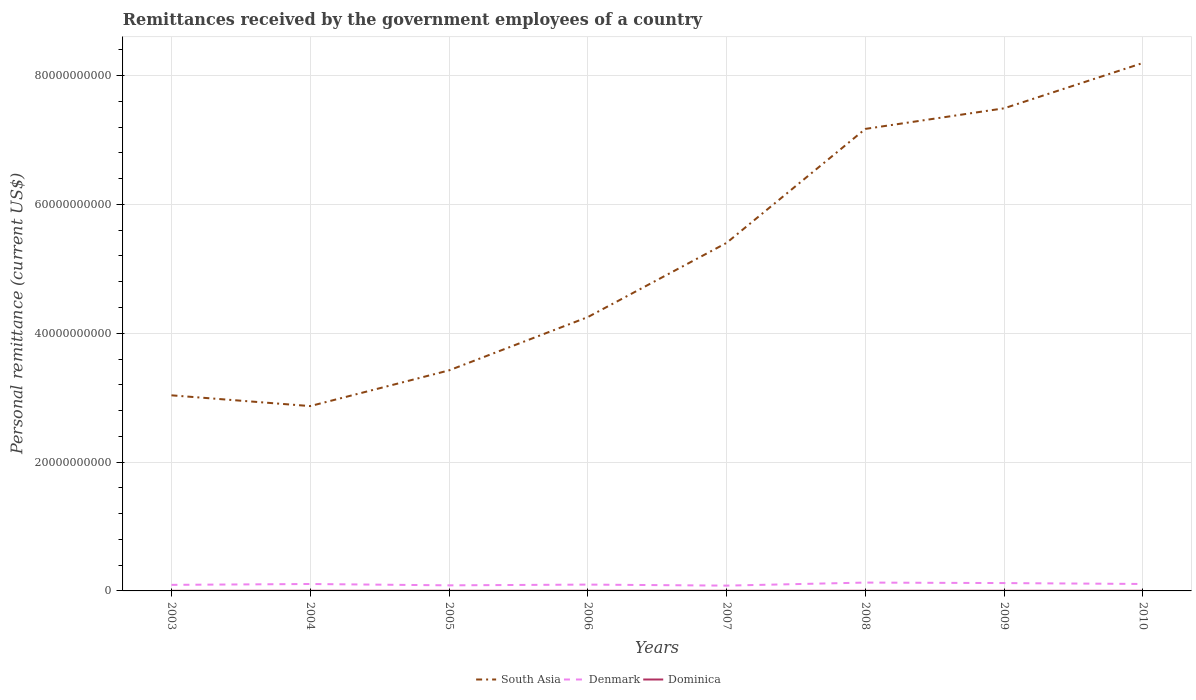Is the number of lines equal to the number of legend labels?
Give a very brief answer. Yes. Across all years, what is the maximum remittances received by the government employees in Denmark?
Keep it short and to the point. 8.23e+08. What is the total remittances received by the government employees in Denmark in the graph?
Make the answer very short. -4.19e+07. What is the difference between the highest and the second highest remittances received by the government employees in Denmark?
Provide a short and direct response. 4.73e+08. What is the difference between the highest and the lowest remittances received by the government employees in South Asia?
Give a very brief answer. 4. How many legend labels are there?
Offer a terse response. 3. What is the title of the graph?
Make the answer very short. Remittances received by the government employees of a country. Does "Paraguay" appear as one of the legend labels in the graph?
Provide a short and direct response. No. What is the label or title of the X-axis?
Offer a terse response. Years. What is the label or title of the Y-axis?
Ensure brevity in your answer.  Personal remittance (current US$). What is the Personal remittance (current US$) in South Asia in 2003?
Make the answer very short. 3.04e+1. What is the Personal remittance (current US$) in Denmark in 2003?
Provide a short and direct response. 9.41e+08. What is the Personal remittance (current US$) in Dominica in 2003?
Give a very brief answer. 1.78e+07. What is the Personal remittance (current US$) of South Asia in 2004?
Offer a very short reply. 2.87e+1. What is the Personal remittance (current US$) of Denmark in 2004?
Offer a terse response. 1.08e+09. What is the Personal remittance (current US$) of Dominica in 2004?
Your answer should be very brief. 2.32e+07. What is the Personal remittance (current US$) in South Asia in 2005?
Offer a terse response. 3.42e+1. What is the Personal remittance (current US$) of Denmark in 2005?
Your response must be concise. 8.67e+08. What is the Personal remittance (current US$) of Dominica in 2005?
Your answer should be compact. 2.18e+07. What is the Personal remittance (current US$) in South Asia in 2006?
Keep it short and to the point. 4.25e+1. What is the Personal remittance (current US$) of Denmark in 2006?
Ensure brevity in your answer.  9.82e+08. What is the Personal remittance (current US$) in Dominica in 2006?
Provide a short and direct response. 2.21e+07. What is the Personal remittance (current US$) of South Asia in 2007?
Keep it short and to the point. 5.40e+1. What is the Personal remittance (current US$) in Denmark in 2007?
Your answer should be very brief. 8.23e+08. What is the Personal remittance (current US$) of Dominica in 2007?
Keep it short and to the point. 2.25e+07. What is the Personal remittance (current US$) of South Asia in 2008?
Give a very brief answer. 7.17e+1. What is the Personal remittance (current US$) in Denmark in 2008?
Give a very brief answer. 1.30e+09. What is the Personal remittance (current US$) in Dominica in 2008?
Keep it short and to the point. 2.27e+07. What is the Personal remittance (current US$) of South Asia in 2009?
Your response must be concise. 7.49e+1. What is the Personal remittance (current US$) of Denmark in 2009?
Provide a short and direct response. 1.22e+09. What is the Personal remittance (current US$) in Dominica in 2009?
Keep it short and to the point. 2.21e+07. What is the Personal remittance (current US$) in South Asia in 2010?
Make the answer very short. 8.20e+1. What is the Personal remittance (current US$) in Denmark in 2010?
Give a very brief answer. 1.08e+09. What is the Personal remittance (current US$) of Dominica in 2010?
Provide a succinct answer. 2.29e+07. Across all years, what is the maximum Personal remittance (current US$) of South Asia?
Provide a short and direct response. 8.20e+1. Across all years, what is the maximum Personal remittance (current US$) of Denmark?
Provide a succinct answer. 1.30e+09. Across all years, what is the maximum Personal remittance (current US$) of Dominica?
Your answer should be compact. 2.32e+07. Across all years, what is the minimum Personal remittance (current US$) in South Asia?
Offer a terse response. 2.87e+1. Across all years, what is the minimum Personal remittance (current US$) of Denmark?
Your answer should be very brief. 8.23e+08. Across all years, what is the minimum Personal remittance (current US$) of Dominica?
Your response must be concise. 1.78e+07. What is the total Personal remittance (current US$) in South Asia in the graph?
Your answer should be very brief. 4.18e+11. What is the total Personal remittance (current US$) of Denmark in the graph?
Give a very brief answer. 8.28e+09. What is the total Personal remittance (current US$) in Dominica in the graph?
Give a very brief answer. 1.75e+08. What is the difference between the Personal remittance (current US$) in South Asia in 2003 and that in 2004?
Keep it short and to the point. 1.67e+09. What is the difference between the Personal remittance (current US$) in Denmark in 2003 and that in 2004?
Provide a succinct answer. -1.35e+08. What is the difference between the Personal remittance (current US$) in Dominica in 2003 and that in 2004?
Ensure brevity in your answer.  -5.33e+06. What is the difference between the Personal remittance (current US$) in South Asia in 2003 and that in 2005?
Offer a very short reply. -3.87e+09. What is the difference between the Personal remittance (current US$) in Denmark in 2003 and that in 2005?
Your answer should be compact. 7.38e+07. What is the difference between the Personal remittance (current US$) in Dominica in 2003 and that in 2005?
Offer a terse response. -3.96e+06. What is the difference between the Personal remittance (current US$) in South Asia in 2003 and that in 2006?
Give a very brief answer. -1.21e+1. What is the difference between the Personal remittance (current US$) of Denmark in 2003 and that in 2006?
Give a very brief answer. -4.19e+07. What is the difference between the Personal remittance (current US$) of Dominica in 2003 and that in 2006?
Offer a terse response. -4.26e+06. What is the difference between the Personal remittance (current US$) in South Asia in 2003 and that in 2007?
Offer a very short reply. -2.37e+1. What is the difference between the Personal remittance (current US$) of Denmark in 2003 and that in 2007?
Give a very brief answer. 1.18e+08. What is the difference between the Personal remittance (current US$) in Dominica in 2003 and that in 2007?
Your answer should be very brief. -4.67e+06. What is the difference between the Personal remittance (current US$) in South Asia in 2003 and that in 2008?
Ensure brevity in your answer.  -4.14e+1. What is the difference between the Personal remittance (current US$) in Denmark in 2003 and that in 2008?
Provide a succinct answer. -3.55e+08. What is the difference between the Personal remittance (current US$) in Dominica in 2003 and that in 2008?
Your answer should be compact. -4.87e+06. What is the difference between the Personal remittance (current US$) of South Asia in 2003 and that in 2009?
Keep it short and to the point. -4.46e+1. What is the difference between the Personal remittance (current US$) in Denmark in 2003 and that in 2009?
Your answer should be compact. -2.78e+08. What is the difference between the Personal remittance (current US$) in Dominica in 2003 and that in 2009?
Offer a terse response. -4.32e+06. What is the difference between the Personal remittance (current US$) of South Asia in 2003 and that in 2010?
Your answer should be compact. -5.16e+1. What is the difference between the Personal remittance (current US$) in Denmark in 2003 and that in 2010?
Provide a short and direct response. -1.37e+08. What is the difference between the Personal remittance (current US$) of Dominica in 2003 and that in 2010?
Provide a short and direct response. -5.07e+06. What is the difference between the Personal remittance (current US$) of South Asia in 2004 and that in 2005?
Your answer should be very brief. -5.54e+09. What is the difference between the Personal remittance (current US$) in Denmark in 2004 and that in 2005?
Your answer should be very brief. 2.09e+08. What is the difference between the Personal remittance (current US$) in Dominica in 2004 and that in 2005?
Ensure brevity in your answer.  1.38e+06. What is the difference between the Personal remittance (current US$) of South Asia in 2004 and that in 2006?
Give a very brief answer. -1.38e+1. What is the difference between the Personal remittance (current US$) of Denmark in 2004 and that in 2006?
Give a very brief answer. 9.29e+07. What is the difference between the Personal remittance (current US$) in Dominica in 2004 and that in 2006?
Make the answer very short. 1.08e+06. What is the difference between the Personal remittance (current US$) in South Asia in 2004 and that in 2007?
Make the answer very short. -2.53e+1. What is the difference between the Personal remittance (current US$) of Denmark in 2004 and that in 2007?
Give a very brief answer. 2.53e+08. What is the difference between the Personal remittance (current US$) of Dominica in 2004 and that in 2007?
Offer a terse response. 6.68e+05. What is the difference between the Personal remittance (current US$) in South Asia in 2004 and that in 2008?
Ensure brevity in your answer.  -4.30e+1. What is the difference between the Personal remittance (current US$) in Denmark in 2004 and that in 2008?
Your answer should be compact. -2.20e+08. What is the difference between the Personal remittance (current US$) in Dominica in 2004 and that in 2008?
Ensure brevity in your answer.  4.64e+05. What is the difference between the Personal remittance (current US$) of South Asia in 2004 and that in 2009?
Ensure brevity in your answer.  -4.62e+1. What is the difference between the Personal remittance (current US$) of Denmark in 2004 and that in 2009?
Keep it short and to the point. -1.44e+08. What is the difference between the Personal remittance (current US$) in Dominica in 2004 and that in 2009?
Offer a very short reply. 1.01e+06. What is the difference between the Personal remittance (current US$) in South Asia in 2004 and that in 2010?
Keep it short and to the point. -5.33e+1. What is the difference between the Personal remittance (current US$) of Denmark in 2004 and that in 2010?
Offer a terse response. -2.14e+06. What is the difference between the Personal remittance (current US$) in Dominica in 2004 and that in 2010?
Give a very brief answer. 2.61e+05. What is the difference between the Personal remittance (current US$) of South Asia in 2005 and that in 2006?
Your answer should be compact. -8.27e+09. What is the difference between the Personal remittance (current US$) of Denmark in 2005 and that in 2006?
Your answer should be compact. -1.16e+08. What is the difference between the Personal remittance (current US$) in Dominica in 2005 and that in 2006?
Your response must be concise. -3.03e+05. What is the difference between the Personal remittance (current US$) in South Asia in 2005 and that in 2007?
Make the answer very short. -1.98e+1. What is the difference between the Personal remittance (current US$) of Denmark in 2005 and that in 2007?
Provide a short and direct response. 4.39e+07. What is the difference between the Personal remittance (current US$) in Dominica in 2005 and that in 2007?
Give a very brief answer. -7.10e+05. What is the difference between the Personal remittance (current US$) of South Asia in 2005 and that in 2008?
Make the answer very short. -3.75e+1. What is the difference between the Personal remittance (current US$) of Denmark in 2005 and that in 2008?
Your answer should be compact. -4.29e+08. What is the difference between the Personal remittance (current US$) in Dominica in 2005 and that in 2008?
Your response must be concise. -9.14e+05. What is the difference between the Personal remittance (current US$) of South Asia in 2005 and that in 2009?
Offer a terse response. -4.07e+1. What is the difference between the Personal remittance (current US$) in Denmark in 2005 and that in 2009?
Keep it short and to the point. -3.52e+08. What is the difference between the Personal remittance (current US$) in Dominica in 2005 and that in 2009?
Provide a succinct answer. -3.66e+05. What is the difference between the Personal remittance (current US$) in South Asia in 2005 and that in 2010?
Offer a very short reply. -4.77e+1. What is the difference between the Personal remittance (current US$) of Denmark in 2005 and that in 2010?
Your answer should be very brief. -2.11e+08. What is the difference between the Personal remittance (current US$) in Dominica in 2005 and that in 2010?
Keep it short and to the point. -1.12e+06. What is the difference between the Personal remittance (current US$) of South Asia in 2006 and that in 2007?
Offer a terse response. -1.15e+1. What is the difference between the Personal remittance (current US$) of Denmark in 2006 and that in 2007?
Your answer should be compact. 1.60e+08. What is the difference between the Personal remittance (current US$) of Dominica in 2006 and that in 2007?
Provide a succinct answer. -4.08e+05. What is the difference between the Personal remittance (current US$) of South Asia in 2006 and that in 2008?
Offer a very short reply. -2.92e+1. What is the difference between the Personal remittance (current US$) of Denmark in 2006 and that in 2008?
Your answer should be very brief. -3.13e+08. What is the difference between the Personal remittance (current US$) in Dominica in 2006 and that in 2008?
Your answer should be compact. -6.11e+05. What is the difference between the Personal remittance (current US$) in South Asia in 2006 and that in 2009?
Offer a very short reply. -3.24e+1. What is the difference between the Personal remittance (current US$) of Denmark in 2006 and that in 2009?
Your answer should be compact. -2.36e+08. What is the difference between the Personal remittance (current US$) of Dominica in 2006 and that in 2009?
Give a very brief answer. -6.35e+04. What is the difference between the Personal remittance (current US$) in South Asia in 2006 and that in 2010?
Your answer should be compact. -3.95e+1. What is the difference between the Personal remittance (current US$) of Denmark in 2006 and that in 2010?
Make the answer very short. -9.51e+07. What is the difference between the Personal remittance (current US$) of Dominica in 2006 and that in 2010?
Give a very brief answer. -8.14e+05. What is the difference between the Personal remittance (current US$) in South Asia in 2007 and that in 2008?
Your response must be concise. -1.77e+1. What is the difference between the Personal remittance (current US$) of Denmark in 2007 and that in 2008?
Your answer should be compact. -4.73e+08. What is the difference between the Personal remittance (current US$) of Dominica in 2007 and that in 2008?
Your response must be concise. -2.04e+05. What is the difference between the Personal remittance (current US$) of South Asia in 2007 and that in 2009?
Offer a very short reply. -2.09e+1. What is the difference between the Personal remittance (current US$) of Denmark in 2007 and that in 2009?
Provide a succinct answer. -3.96e+08. What is the difference between the Personal remittance (current US$) of Dominica in 2007 and that in 2009?
Make the answer very short. 3.44e+05. What is the difference between the Personal remittance (current US$) in South Asia in 2007 and that in 2010?
Make the answer very short. -2.79e+1. What is the difference between the Personal remittance (current US$) in Denmark in 2007 and that in 2010?
Your response must be concise. -2.55e+08. What is the difference between the Personal remittance (current US$) in Dominica in 2007 and that in 2010?
Provide a short and direct response. -4.07e+05. What is the difference between the Personal remittance (current US$) of South Asia in 2008 and that in 2009?
Provide a short and direct response. -3.20e+09. What is the difference between the Personal remittance (current US$) in Denmark in 2008 and that in 2009?
Provide a short and direct response. 7.65e+07. What is the difference between the Personal remittance (current US$) of Dominica in 2008 and that in 2009?
Give a very brief answer. 5.48e+05. What is the difference between the Personal remittance (current US$) in South Asia in 2008 and that in 2010?
Keep it short and to the point. -1.02e+1. What is the difference between the Personal remittance (current US$) in Denmark in 2008 and that in 2010?
Offer a very short reply. 2.18e+08. What is the difference between the Personal remittance (current US$) in Dominica in 2008 and that in 2010?
Your answer should be very brief. -2.03e+05. What is the difference between the Personal remittance (current US$) of South Asia in 2009 and that in 2010?
Your answer should be compact. -7.04e+09. What is the difference between the Personal remittance (current US$) in Denmark in 2009 and that in 2010?
Your answer should be compact. 1.41e+08. What is the difference between the Personal remittance (current US$) in Dominica in 2009 and that in 2010?
Make the answer very short. -7.51e+05. What is the difference between the Personal remittance (current US$) in South Asia in 2003 and the Personal remittance (current US$) in Denmark in 2004?
Keep it short and to the point. 2.93e+1. What is the difference between the Personal remittance (current US$) in South Asia in 2003 and the Personal remittance (current US$) in Dominica in 2004?
Provide a short and direct response. 3.03e+1. What is the difference between the Personal remittance (current US$) in Denmark in 2003 and the Personal remittance (current US$) in Dominica in 2004?
Give a very brief answer. 9.17e+08. What is the difference between the Personal remittance (current US$) in South Asia in 2003 and the Personal remittance (current US$) in Denmark in 2005?
Ensure brevity in your answer.  2.95e+1. What is the difference between the Personal remittance (current US$) of South Asia in 2003 and the Personal remittance (current US$) of Dominica in 2005?
Your answer should be compact. 3.03e+1. What is the difference between the Personal remittance (current US$) in Denmark in 2003 and the Personal remittance (current US$) in Dominica in 2005?
Your answer should be very brief. 9.19e+08. What is the difference between the Personal remittance (current US$) of South Asia in 2003 and the Personal remittance (current US$) of Denmark in 2006?
Keep it short and to the point. 2.94e+1. What is the difference between the Personal remittance (current US$) in South Asia in 2003 and the Personal remittance (current US$) in Dominica in 2006?
Provide a short and direct response. 3.03e+1. What is the difference between the Personal remittance (current US$) of Denmark in 2003 and the Personal remittance (current US$) of Dominica in 2006?
Offer a very short reply. 9.18e+08. What is the difference between the Personal remittance (current US$) in South Asia in 2003 and the Personal remittance (current US$) in Denmark in 2007?
Provide a succinct answer. 2.95e+1. What is the difference between the Personal remittance (current US$) in South Asia in 2003 and the Personal remittance (current US$) in Dominica in 2007?
Your response must be concise. 3.03e+1. What is the difference between the Personal remittance (current US$) in Denmark in 2003 and the Personal remittance (current US$) in Dominica in 2007?
Your answer should be very brief. 9.18e+08. What is the difference between the Personal remittance (current US$) in South Asia in 2003 and the Personal remittance (current US$) in Denmark in 2008?
Make the answer very short. 2.91e+1. What is the difference between the Personal remittance (current US$) of South Asia in 2003 and the Personal remittance (current US$) of Dominica in 2008?
Keep it short and to the point. 3.03e+1. What is the difference between the Personal remittance (current US$) in Denmark in 2003 and the Personal remittance (current US$) in Dominica in 2008?
Offer a terse response. 9.18e+08. What is the difference between the Personal remittance (current US$) of South Asia in 2003 and the Personal remittance (current US$) of Denmark in 2009?
Provide a short and direct response. 2.91e+1. What is the difference between the Personal remittance (current US$) in South Asia in 2003 and the Personal remittance (current US$) in Dominica in 2009?
Provide a short and direct response. 3.03e+1. What is the difference between the Personal remittance (current US$) in Denmark in 2003 and the Personal remittance (current US$) in Dominica in 2009?
Your answer should be very brief. 9.18e+08. What is the difference between the Personal remittance (current US$) in South Asia in 2003 and the Personal remittance (current US$) in Denmark in 2010?
Offer a very short reply. 2.93e+1. What is the difference between the Personal remittance (current US$) of South Asia in 2003 and the Personal remittance (current US$) of Dominica in 2010?
Provide a short and direct response. 3.03e+1. What is the difference between the Personal remittance (current US$) in Denmark in 2003 and the Personal remittance (current US$) in Dominica in 2010?
Give a very brief answer. 9.18e+08. What is the difference between the Personal remittance (current US$) in South Asia in 2004 and the Personal remittance (current US$) in Denmark in 2005?
Provide a succinct answer. 2.78e+1. What is the difference between the Personal remittance (current US$) of South Asia in 2004 and the Personal remittance (current US$) of Dominica in 2005?
Offer a very short reply. 2.87e+1. What is the difference between the Personal remittance (current US$) of Denmark in 2004 and the Personal remittance (current US$) of Dominica in 2005?
Your response must be concise. 1.05e+09. What is the difference between the Personal remittance (current US$) in South Asia in 2004 and the Personal remittance (current US$) in Denmark in 2006?
Give a very brief answer. 2.77e+1. What is the difference between the Personal remittance (current US$) of South Asia in 2004 and the Personal remittance (current US$) of Dominica in 2006?
Provide a short and direct response. 2.87e+1. What is the difference between the Personal remittance (current US$) in Denmark in 2004 and the Personal remittance (current US$) in Dominica in 2006?
Make the answer very short. 1.05e+09. What is the difference between the Personal remittance (current US$) of South Asia in 2004 and the Personal remittance (current US$) of Denmark in 2007?
Your response must be concise. 2.79e+1. What is the difference between the Personal remittance (current US$) in South Asia in 2004 and the Personal remittance (current US$) in Dominica in 2007?
Make the answer very short. 2.87e+1. What is the difference between the Personal remittance (current US$) in Denmark in 2004 and the Personal remittance (current US$) in Dominica in 2007?
Offer a very short reply. 1.05e+09. What is the difference between the Personal remittance (current US$) in South Asia in 2004 and the Personal remittance (current US$) in Denmark in 2008?
Your answer should be very brief. 2.74e+1. What is the difference between the Personal remittance (current US$) in South Asia in 2004 and the Personal remittance (current US$) in Dominica in 2008?
Your response must be concise. 2.87e+1. What is the difference between the Personal remittance (current US$) of Denmark in 2004 and the Personal remittance (current US$) of Dominica in 2008?
Ensure brevity in your answer.  1.05e+09. What is the difference between the Personal remittance (current US$) of South Asia in 2004 and the Personal remittance (current US$) of Denmark in 2009?
Make the answer very short. 2.75e+1. What is the difference between the Personal remittance (current US$) in South Asia in 2004 and the Personal remittance (current US$) in Dominica in 2009?
Your answer should be compact. 2.87e+1. What is the difference between the Personal remittance (current US$) of Denmark in 2004 and the Personal remittance (current US$) of Dominica in 2009?
Offer a terse response. 1.05e+09. What is the difference between the Personal remittance (current US$) of South Asia in 2004 and the Personal remittance (current US$) of Denmark in 2010?
Offer a very short reply. 2.76e+1. What is the difference between the Personal remittance (current US$) in South Asia in 2004 and the Personal remittance (current US$) in Dominica in 2010?
Keep it short and to the point. 2.87e+1. What is the difference between the Personal remittance (current US$) of Denmark in 2004 and the Personal remittance (current US$) of Dominica in 2010?
Keep it short and to the point. 1.05e+09. What is the difference between the Personal remittance (current US$) in South Asia in 2005 and the Personal remittance (current US$) in Denmark in 2006?
Keep it short and to the point. 3.33e+1. What is the difference between the Personal remittance (current US$) of South Asia in 2005 and the Personal remittance (current US$) of Dominica in 2006?
Your answer should be very brief. 3.42e+1. What is the difference between the Personal remittance (current US$) of Denmark in 2005 and the Personal remittance (current US$) of Dominica in 2006?
Your answer should be compact. 8.45e+08. What is the difference between the Personal remittance (current US$) of South Asia in 2005 and the Personal remittance (current US$) of Denmark in 2007?
Keep it short and to the point. 3.34e+1. What is the difference between the Personal remittance (current US$) in South Asia in 2005 and the Personal remittance (current US$) in Dominica in 2007?
Your answer should be compact. 3.42e+1. What is the difference between the Personal remittance (current US$) of Denmark in 2005 and the Personal remittance (current US$) of Dominica in 2007?
Your answer should be compact. 8.44e+08. What is the difference between the Personal remittance (current US$) of South Asia in 2005 and the Personal remittance (current US$) of Denmark in 2008?
Your answer should be very brief. 3.29e+1. What is the difference between the Personal remittance (current US$) in South Asia in 2005 and the Personal remittance (current US$) in Dominica in 2008?
Make the answer very short. 3.42e+1. What is the difference between the Personal remittance (current US$) of Denmark in 2005 and the Personal remittance (current US$) of Dominica in 2008?
Provide a short and direct response. 8.44e+08. What is the difference between the Personal remittance (current US$) in South Asia in 2005 and the Personal remittance (current US$) in Denmark in 2009?
Provide a succinct answer. 3.30e+1. What is the difference between the Personal remittance (current US$) of South Asia in 2005 and the Personal remittance (current US$) of Dominica in 2009?
Make the answer very short. 3.42e+1. What is the difference between the Personal remittance (current US$) of Denmark in 2005 and the Personal remittance (current US$) of Dominica in 2009?
Make the answer very short. 8.45e+08. What is the difference between the Personal remittance (current US$) in South Asia in 2005 and the Personal remittance (current US$) in Denmark in 2010?
Offer a very short reply. 3.32e+1. What is the difference between the Personal remittance (current US$) in South Asia in 2005 and the Personal remittance (current US$) in Dominica in 2010?
Keep it short and to the point. 3.42e+1. What is the difference between the Personal remittance (current US$) of Denmark in 2005 and the Personal remittance (current US$) of Dominica in 2010?
Your answer should be very brief. 8.44e+08. What is the difference between the Personal remittance (current US$) in South Asia in 2006 and the Personal remittance (current US$) in Denmark in 2007?
Keep it short and to the point. 4.17e+1. What is the difference between the Personal remittance (current US$) of South Asia in 2006 and the Personal remittance (current US$) of Dominica in 2007?
Provide a succinct answer. 4.25e+1. What is the difference between the Personal remittance (current US$) of Denmark in 2006 and the Personal remittance (current US$) of Dominica in 2007?
Offer a very short reply. 9.60e+08. What is the difference between the Personal remittance (current US$) in South Asia in 2006 and the Personal remittance (current US$) in Denmark in 2008?
Your response must be concise. 4.12e+1. What is the difference between the Personal remittance (current US$) of South Asia in 2006 and the Personal remittance (current US$) of Dominica in 2008?
Offer a very short reply. 4.25e+1. What is the difference between the Personal remittance (current US$) in Denmark in 2006 and the Personal remittance (current US$) in Dominica in 2008?
Make the answer very short. 9.60e+08. What is the difference between the Personal remittance (current US$) in South Asia in 2006 and the Personal remittance (current US$) in Denmark in 2009?
Keep it short and to the point. 4.13e+1. What is the difference between the Personal remittance (current US$) in South Asia in 2006 and the Personal remittance (current US$) in Dominica in 2009?
Offer a terse response. 4.25e+1. What is the difference between the Personal remittance (current US$) in Denmark in 2006 and the Personal remittance (current US$) in Dominica in 2009?
Your answer should be very brief. 9.60e+08. What is the difference between the Personal remittance (current US$) of South Asia in 2006 and the Personal remittance (current US$) of Denmark in 2010?
Your answer should be very brief. 4.14e+1. What is the difference between the Personal remittance (current US$) in South Asia in 2006 and the Personal remittance (current US$) in Dominica in 2010?
Provide a short and direct response. 4.25e+1. What is the difference between the Personal remittance (current US$) of Denmark in 2006 and the Personal remittance (current US$) of Dominica in 2010?
Your response must be concise. 9.60e+08. What is the difference between the Personal remittance (current US$) in South Asia in 2007 and the Personal remittance (current US$) in Denmark in 2008?
Give a very brief answer. 5.27e+1. What is the difference between the Personal remittance (current US$) of South Asia in 2007 and the Personal remittance (current US$) of Dominica in 2008?
Offer a very short reply. 5.40e+1. What is the difference between the Personal remittance (current US$) in Denmark in 2007 and the Personal remittance (current US$) in Dominica in 2008?
Your answer should be compact. 8.00e+08. What is the difference between the Personal remittance (current US$) in South Asia in 2007 and the Personal remittance (current US$) in Denmark in 2009?
Provide a short and direct response. 5.28e+1. What is the difference between the Personal remittance (current US$) in South Asia in 2007 and the Personal remittance (current US$) in Dominica in 2009?
Offer a very short reply. 5.40e+1. What is the difference between the Personal remittance (current US$) of Denmark in 2007 and the Personal remittance (current US$) of Dominica in 2009?
Provide a succinct answer. 8.01e+08. What is the difference between the Personal remittance (current US$) in South Asia in 2007 and the Personal remittance (current US$) in Denmark in 2010?
Your answer should be very brief. 5.30e+1. What is the difference between the Personal remittance (current US$) in South Asia in 2007 and the Personal remittance (current US$) in Dominica in 2010?
Provide a short and direct response. 5.40e+1. What is the difference between the Personal remittance (current US$) of Denmark in 2007 and the Personal remittance (current US$) of Dominica in 2010?
Ensure brevity in your answer.  8.00e+08. What is the difference between the Personal remittance (current US$) of South Asia in 2008 and the Personal remittance (current US$) of Denmark in 2009?
Give a very brief answer. 7.05e+1. What is the difference between the Personal remittance (current US$) in South Asia in 2008 and the Personal remittance (current US$) in Dominica in 2009?
Provide a succinct answer. 7.17e+1. What is the difference between the Personal remittance (current US$) in Denmark in 2008 and the Personal remittance (current US$) in Dominica in 2009?
Offer a terse response. 1.27e+09. What is the difference between the Personal remittance (current US$) of South Asia in 2008 and the Personal remittance (current US$) of Denmark in 2010?
Offer a very short reply. 7.06e+1. What is the difference between the Personal remittance (current US$) in South Asia in 2008 and the Personal remittance (current US$) in Dominica in 2010?
Give a very brief answer. 7.17e+1. What is the difference between the Personal remittance (current US$) of Denmark in 2008 and the Personal remittance (current US$) of Dominica in 2010?
Offer a terse response. 1.27e+09. What is the difference between the Personal remittance (current US$) of South Asia in 2009 and the Personal remittance (current US$) of Denmark in 2010?
Offer a very short reply. 7.38e+1. What is the difference between the Personal remittance (current US$) of South Asia in 2009 and the Personal remittance (current US$) of Dominica in 2010?
Your response must be concise. 7.49e+1. What is the difference between the Personal remittance (current US$) of Denmark in 2009 and the Personal remittance (current US$) of Dominica in 2010?
Your answer should be compact. 1.20e+09. What is the average Personal remittance (current US$) in South Asia per year?
Make the answer very short. 5.23e+1. What is the average Personal remittance (current US$) of Denmark per year?
Provide a short and direct response. 1.03e+09. What is the average Personal remittance (current US$) in Dominica per year?
Your answer should be compact. 2.19e+07. In the year 2003, what is the difference between the Personal remittance (current US$) of South Asia and Personal remittance (current US$) of Denmark?
Ensure brevity in your answer.  2.94e+1. In the year 2003, what is the difference between the Personal remittance (current US$) of South Asia and Personal remittance (current US$) of Dominica?
Make the answer very short. 3.03e+1. In the year 2003, what is the difference between the Personal remittance (current US$) in Denmark and Personal remittance (current US$) in Dominica?
Make the answer very short. 9.23e+08. In the year 2004, what is the difference between the Personal remittance (current US$) in South Asia and Personal remittance (current US$) in Denmark?
Give a very brief answer. 2.76e+1. In the year 2004, what is the difference between the Personal remittance (current US$) in South Asia and Personal remittance (current US$) in Dominica?
Your answer should be very brief. 2.87e+1. In the year 2004, what is the difference between the Personal remittance (current US$) in Denmark and Personal remittance (current US$) in Dominica?
Provide a succinct answer. 1.05e+09. In the year 2005, what is the difference between the Personal remittance (current US$) of South Asia and Personal remittance (current US$) of Denmark?
Ensure brevity in your answer.  3.34e+1. In the year 2005, what is the difference between the Personal remittance (current US$) in South Asia and Personal remittance (current US$) in Dominica?
Make the answer very short. 3.42e+1. In the year 2005, what is the difference between the Personal remittance (current US$) of Denmark and Personal remittance (current US$) of Dominica?
Keep it short and to the point. 8.45e+08. In the year 2006, what is the difference between the Personal remittance (current US$) of South Asia and Personal remittance (current US$) of Denmark?
Provide a short and direct response. 4.15e+1. In the year 2006, what is the difference between the Personal remittance (current US$) of South Asia and Personal remittance (current US$) of Dominica?
Give a very brief answer. 4.25e+1. In the year 2006, what is the difference between the Personal remittance (current US$) of Denmark and Personal remittance (current US$) of Dominica?
Your answer should be very brief. 9.60e+08. In the year 2007, what is the difference between the Personal remittance (current US$) of South Asia and Personal remittance (current US$) of Denmark?
Make the answer very short. 5.32e+1. In the year 2007, what is the difference between the Personal remittance (current US$) of South Asia and Personal remittance (current US$) of Dominica?
Make the answer very short. 5.40e+1. In the year 2007, what is the difference between the Personal remittance (current US$) in Denmark and Personal remittance (current US$) in Dominica?
Keep it short and to the point. 8.00e+08. In the year 2008, what is the difference between the Personal remittance (current US$) of South Asia and Personal remittance (current US$) of Denmark?
Your answer should be very brief. 7.04e+1. In the year 2008, what is the difference between the Personal remittance (current US$) of South Asia and Personal remittance (current US$) of Dominica?
Your answer should be compact. 7.17e+1. In the year 2008, what is the difference between the Personal remittance (current US$) in Denmark and Personal remittance (current US$) in Dominica?
Your response must be concise. 1.27e+09. In the year 2009, what is the difference between the Personal remittance (current US$) of South Asia and Personal remittance (current US$) of Denmark?
Provide a succinct answer. 7.37e+1. In the year 2009, what is the difference between the Personal remittance (current US$) in South Asia and Personal remittance (current US$) in Dominica?
Provide a short and direct response. 7.49e+1. In the year 2009, what is the difference between the Personal remittance (current US$) of Denmark and Personal remittance (current US$) of Dominica?
Give a very brief answer. 1.20e+09. In the year 2010, what is the difference between the Personal remittance (current US$) in South Asia and Personal remittance (current US$) in Denmark?
Make the answer very short. 8.09e+1. In the year 2010, what is the difference between the Personal remittance (current US$) in South Asia and Personal remittance (current US$) in Dominica?
Provide a short and direct response. 8.19e+1. In the year 2010, what is the difference between the Personal remittance (current US$) of Denmark and Personal remittance (current US$) of Dominica?
Keep it short and to the point. 1.05e+09. What is the ratio of the Personal remittance (current US$) in South Asia in 2003 to that in 2004?
Ensure brevity in your answer.  1.06. What is the ratio of the Personal remittance (current US$) of Denmark in 2003 to that in 2004?
Offer a very short reply. 0.87. What is the ratio of the Personal remittance (current US$) of Dominica in 2003 to that in 2004?
Offer a terse response. 0.77. What is the ratio of the Personal remittance (current US$) of South Asia in 2003 to that in 2005?
Make the answer very short. 0.89. What is the ratio of the Personal remittance (current US$) of Denmark in 2003 to that in 2005?
Offer a terse response. 1.09. What is the ratio of the Personal remittance (current US$) in Dominica in 2003 to that in 2005?
Make the answer very short. 0.82. What is the ratio of the Personal remittance (current US$) of South Asia in 2003 to that in 2006?
Your answer should be compact. 0.71. What is the ratio of the Personal remittance (current US$) of Denmark in 2003 to that in 2006?
Make the answer very short. 0.96. What is the ratio of the Personal remittance (current US$) in Dominica in 2003 to that in 2006?
Offer a terse response. 0.81. What is the ratio of the Personal remittance (current US$) in South Asia in 2003 to that in 2007?
Make the answer very short. 0.56. What is the ratio of the Personal remittance (current US$) of Denmark in 2003 to that in 2007?
Your answer should be compact. 1.14. What is the ratio of the Personal remittance (current US$) of Dominica in 2003 to that in 2007?
Provide a succinct answer. 0.79. What is the ratio of the Personal remittance (current US$) in South Asia in 2003 to that in 2008?
Offer a very short reply. 0.42. What is the ratio of the Personal remittance (current US$) in Denmark in 2003 to that in 2008?
Offer a terse response. 0.73. What is the ratio of the Personal remittance (current US$) in Dominica in 2003 to that in 2008?
Offer a terse response. 0.79. What is the ratio of the Personal remittance (current US$) in South Asia in 2003 to that in 2009?
Provide a succinct answer. 0.41. What is the ratio of the Personal remittance (current US$) of Denmark in 2003 to that in 2009?
Give a very brief answer. 0.77. What is the ratio of the Personal remittance (current US$) of Dominica in 2003 to that in 2009?
Your answer should be compact. 0.8. What is the ratio of the Personal remittance (current US$) of South Asia in 2003 to that in 2010?
Your answer should be compact. 0.37. What is the ratio of the Personal remittance (current US$) in Denmark in 2003 to that in 2010?
Ensure brevity in your answer.  0.87. What is the ratio of the Personal remittance (current US$) of Dominica in 2003 to that in 2010?
Your response must be concise. 0.78. What is the ratio of the Personal remittance (current US$) in South Asia in 2004 to that in 2005?
Keep it short and to the point. 0.84. What is the ratio of the Personal remittance (current US$) in Denmark in 2004 to that in 2005?
Your answer should be very brief. 1.24. What is the ratio of the Personal remittance (current US$) in Dominica in 2004 to that in 2005?
Your answer should be compact. 1.06. What is the ratio of the Personal remittance (current US$) in South Asia in 2004 to that in 2006?
Your answer should be very brief. 0.68. What is the ratio of the Personal remittance (current US$) in Denmark in 2004 to that in 2006?
Offer a terse response. 1.09. What is the ratio of the Personal remittance (current US$) of Dominica in 2004 to that in 2006?
Make the answer very short. 1.05. What is the ratio of the Personal remittance (current US$) of South Asia in 2004 to that in 2007?
Give a very brief answer. 0.53. What is the ratio of the Personal remittance (current US$) in Denmark in 2004 to that in 2007?
Your response must be concise. 1.31. What is the ratio of the Personal remittance (current US$) of Dominica in 2004 to that in 2007?
Ensure brevity in your answer.  1.03. What is the ratio of the Personal remittance (current US$) of South Asia in 2004 to that in 2008?
Your response must be concise. 0.4. What is the ratio of the Personal remittance (current US$) in Denmark in 2004 to that in 2008?
Provide a succinct answer. 0.83. What is the ratio of the Personal remittance (current US$) in Dominica in 2004 to that in 2008?
Provide a short and direct response. 1.02. What is the ratio of the Personal remittance (current US$) of South Asia in 2004 to that in 2009?
Offer a very short reply. 0.38. What is the ratio of the Personal remittance (current US$) of Denmark in 2004 to that in 2009?
Give a very brief answer. 0.88. What is the ratio of the Personal remittance (current US$) of Dominica in 2004 to that in 2009?
Your response must be concise. 1.05. What is the ratio of the Personal remittance (current US$) in South Asia in 2004 to that in 2010?
Your response must be concise. 0.35. What is the ratio of the Personal remittance (current US$) in Dominica in 2004 to that in 2010?
Make the answer very short. 1.01. What is the ratio of the Personal remittance (current US$) of South Asia in 2005 to that in 2006?
Your answer should be compact. 0.81. What is the ratio of the Personal remittance (current US$) of Denmark in 2005 to that in 2006?
Ensure brevity in your answer.  0.88. What is the ratio of the Personal remittance (current US$) of Dominica in 2005 to that in 2006?
Give a very brief answer. 0.99. What is the ratio of the Personal remittance (current US$) of South Asia in 2005 to that in 2007?
Your answer should be very brief. 0.63. What is the ratio of the Personal remittance (current US$) in Denmark in 2005 to that in 2007?
Provide a short and direct response. 1.05. What is the ratio of the Personal remittance (current US$) in Dominica in 2005 to that in 2007?
Give a very brief answer. 0.97. What is the ratio of the Personal remittance (current US$) of South Asia in 2005 to that in 2008?
Ensure brevity in your answer.  0.48. What is the ratio of the Personal remittance (current US$) in Denmark in 2005 to that in 2008?
Ensure brevity in your answer.  0.67. What is the ratio of the Personal remittance (current US$) in Dominica in 2005 to that in 2008?
Your answer should be compact. 0.96. What is the ratio of the Personal remittance (current US$) of South Asia in 2005 to that in 2009?
Provide a succinct answer. 0.46. What is the ratio of the Personal remittance (current US$) of Denmark in 2005 to that in 2009?
Your answer should be compact. 0.71. What is the ratio of the Personal remittance (current US$) in Dominica in 2005 to that in 2009?
Your answer should be compact. 0.98. What is the ratio of the Personal remittance (current US$) in South Asia in 2005 to that in 2010?
Give a very brief answer. 0.42. What is the ratio of the Personal remittance (current US$) in Denmark in 2005 to that in 2010?
Make the answer very short. 0.8. What is the ratio of the Personal remittance (current US$) in Dominica in 2005 to that in 2010?
Make the answer very short. 0.95. What is the ratio of the Personal remittance (current US$) of South Asia in 2006 to that in 2007?
Provide a succinct answer. 0.79. What is the ratio of the Personal remittance (current US$) in Denmark in 2006 to that in 2007?
Your response must be concise. 1.19. What is the ratio of the Personal remittance (current US$) of Dominica in 2006 to that in 2007?
Offer a terse response. 0.98. What is the ratio of the Personal remittance (current US$) in South Asia in 2006 to that in 2008?
Your answer should be compact. 0.59. What is the ratio of the Personal remittance (current US$) of Denmark in 2006 to that in 2008?
Your answer should be compact. 0.76. What is the ratio of the Personal remittance (current US$) in Dominica in 2006 to that in 2008?
Keep it short and to the point. 0.97. What is the ratio of the Personal remittance (current US$) of South Asia in 2006 to that in 2009?
Offer a terse response. 0.57. What is the ratio of the Personal remittance (current US$) of Denmark in 2006 to that in 2009?
Offer a terse response. 0.81. What is the ratio of the Personal remittance (current US$) of Dominica in 2006 to that in 2009?
Your response must be concise. 1. What is the ratio of the Personal remittance (current US$) in South Asia in 2006 to that in 2010?
Offer a terse response. 0.52. What is the ratio of the Personal remittance (current US$) of Denmark in 2006 to that in 2010?
Offer a terse response. 0.91. What is the ratio of the Personal remittance (current US$) of Dominica in 2006 to that in 2010?
Offer a terse response. 0.96. What is the ratio of the Personal remittance (current US$) in South Asia in 2007 to that in 2008?
Keep it short and to the point. 0.75. What is the ratio of the Personal remittance (current US$) of Denmark in 2007 to that in 2008?
Ensure brevity in your answer.  0.64. What is the ratio of the Personal remittance (current US$) in South Asia in 2007 to that in 2009?
Offer a very short reply. 0.72. What is the ratio of the Personal remittance (current US$) in Denmark in 2007 to that in 2009?
Your answer should be very brief. 0.68. What is the ratio of the Personal remittance (current US$) of Dominica in 2007 to that in 2009?
Make the answer very short. 1.02. What is the ratio of the Personal remittance (current US$) of South Asia in 2007 to that in 2010?
Ensure brevity in your answer.  0.66. What is the ratio of the Personal remittance (current US$) in Denmark in 2007 to that in 2010?
Your answer should be very brief. 0.76. What is the ratio of the Personal remittance (current US$) in Dominica in 2007 to that in 2010?
Your answer should be compact. 0.98. What is the ratio of the Personal remittance (current US$) in South Asia in 2008 to that in 2009?
Ensure brevity in your answer.  0.96. What is the ratio of the Personal remittance (current US$) in Denmark in 2008 to that in 2009?
Make the answer very short. 1.06. What is the ratio of the Personal remittance (current US$) in Dominica in 2008 to that in 2009?
Make the answer very short. 1.02. What is the ratio of the Personal remittance (current US$) of South Asia in 2008 to that in 2010?
Provide a short and direct response. 0.88. What is the ratio of the Personal remittance (current US$) of Denmark in 2008 to that in 2010?
Ensure brevity in your answer.  1.2. What is the ratio of the Personal remittance (current US$) in South Asia in 2009 to that in 2010?
Make the answer very short. 0.91. What is the ratio of the Personal remittance (current US$) in Denmark in 2009 to that in 2010?
Offer a terse response. 1.13. What is the ratio of the Personal remittance (current US$) of Dominica in 2009 to that in 2010?
Offer a terse response. 0.97. What is the difference between the highest and the second highest Personal remittance (current US$) of South Asia?
Give a very brief answer. 7.04e+09. What is the difference between the highest and the second highest Personal remittance (current US$) in Denmark?
Keep it short and to the point. 7.65e+07. What is the difference between the highest and the second highest Personal remittance (current US$) in Dominica?
Your answer should be compact. 2.61e+05. What is the difference between the highest and the lowest Personal remittance (current US$) of South Asia?
Ensure brevity in your answer.  5.33e+1. What is the difference between the highest and the lowest Personal remittance (current US$) of Denmark?
Offer a terse response. 4.73e+08. What is the difference between the highest and the lowest Personal remittance (current US$) of Dominica?
Offer a very short reply. 5.33e+06. 